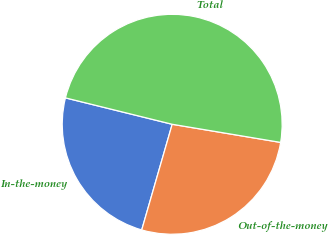Convert chart. <chart><loc_0><loc_0><loc_500><loc_500><pie_chart><fcel>In-the-money<fcel>Out-of-the-money<fcel>Total<nl><fcel>24.39%<fcel>26.83%<fcel>48.78%<nl></chart> 